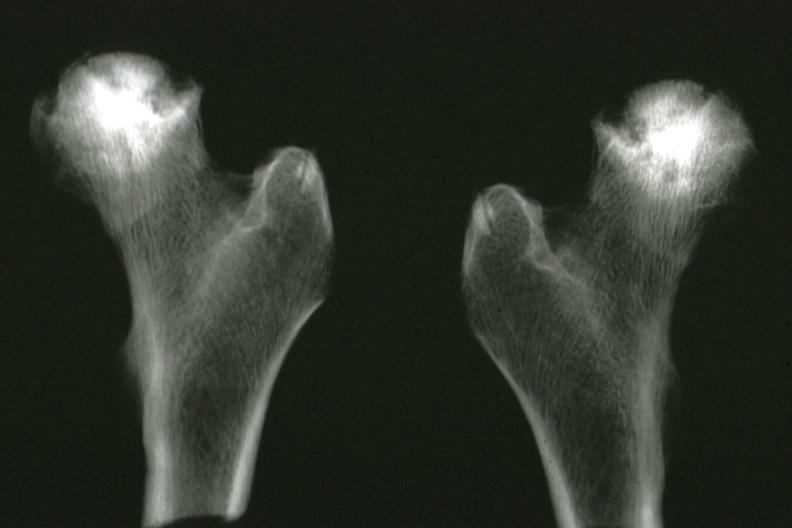what removed at autopsy good illustration?
Answer the question using a single word or phrase. X-ray of femoral heads 